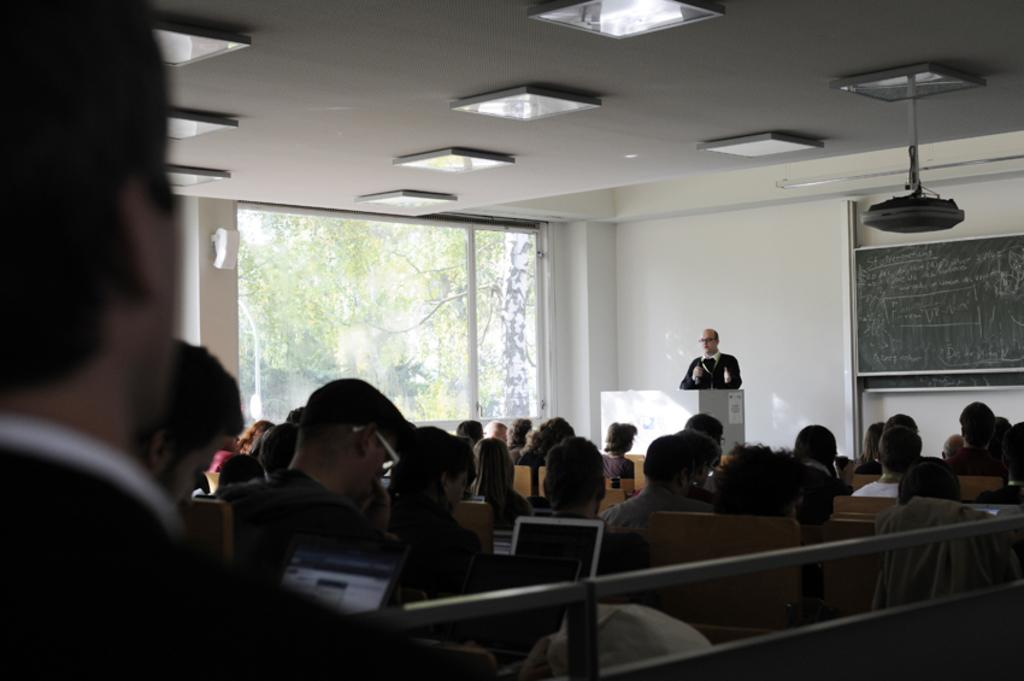What are the people in the foreground of the image doing? The people in the foreground of the image are sitting in front of laptops. Can you describe the man in the image? There is a man standing in the image, and he is standing in front of a desk. What can be seen in the background of the image? In the background of the image, there is a board, a window, lamps, and trees. What type of authority figure can be seen in the image? There is no authority figure present in the image. Can you describe the fear that the deer in the image is experiencing? There are no deer present in the image, and therefore no fear can be observed. 